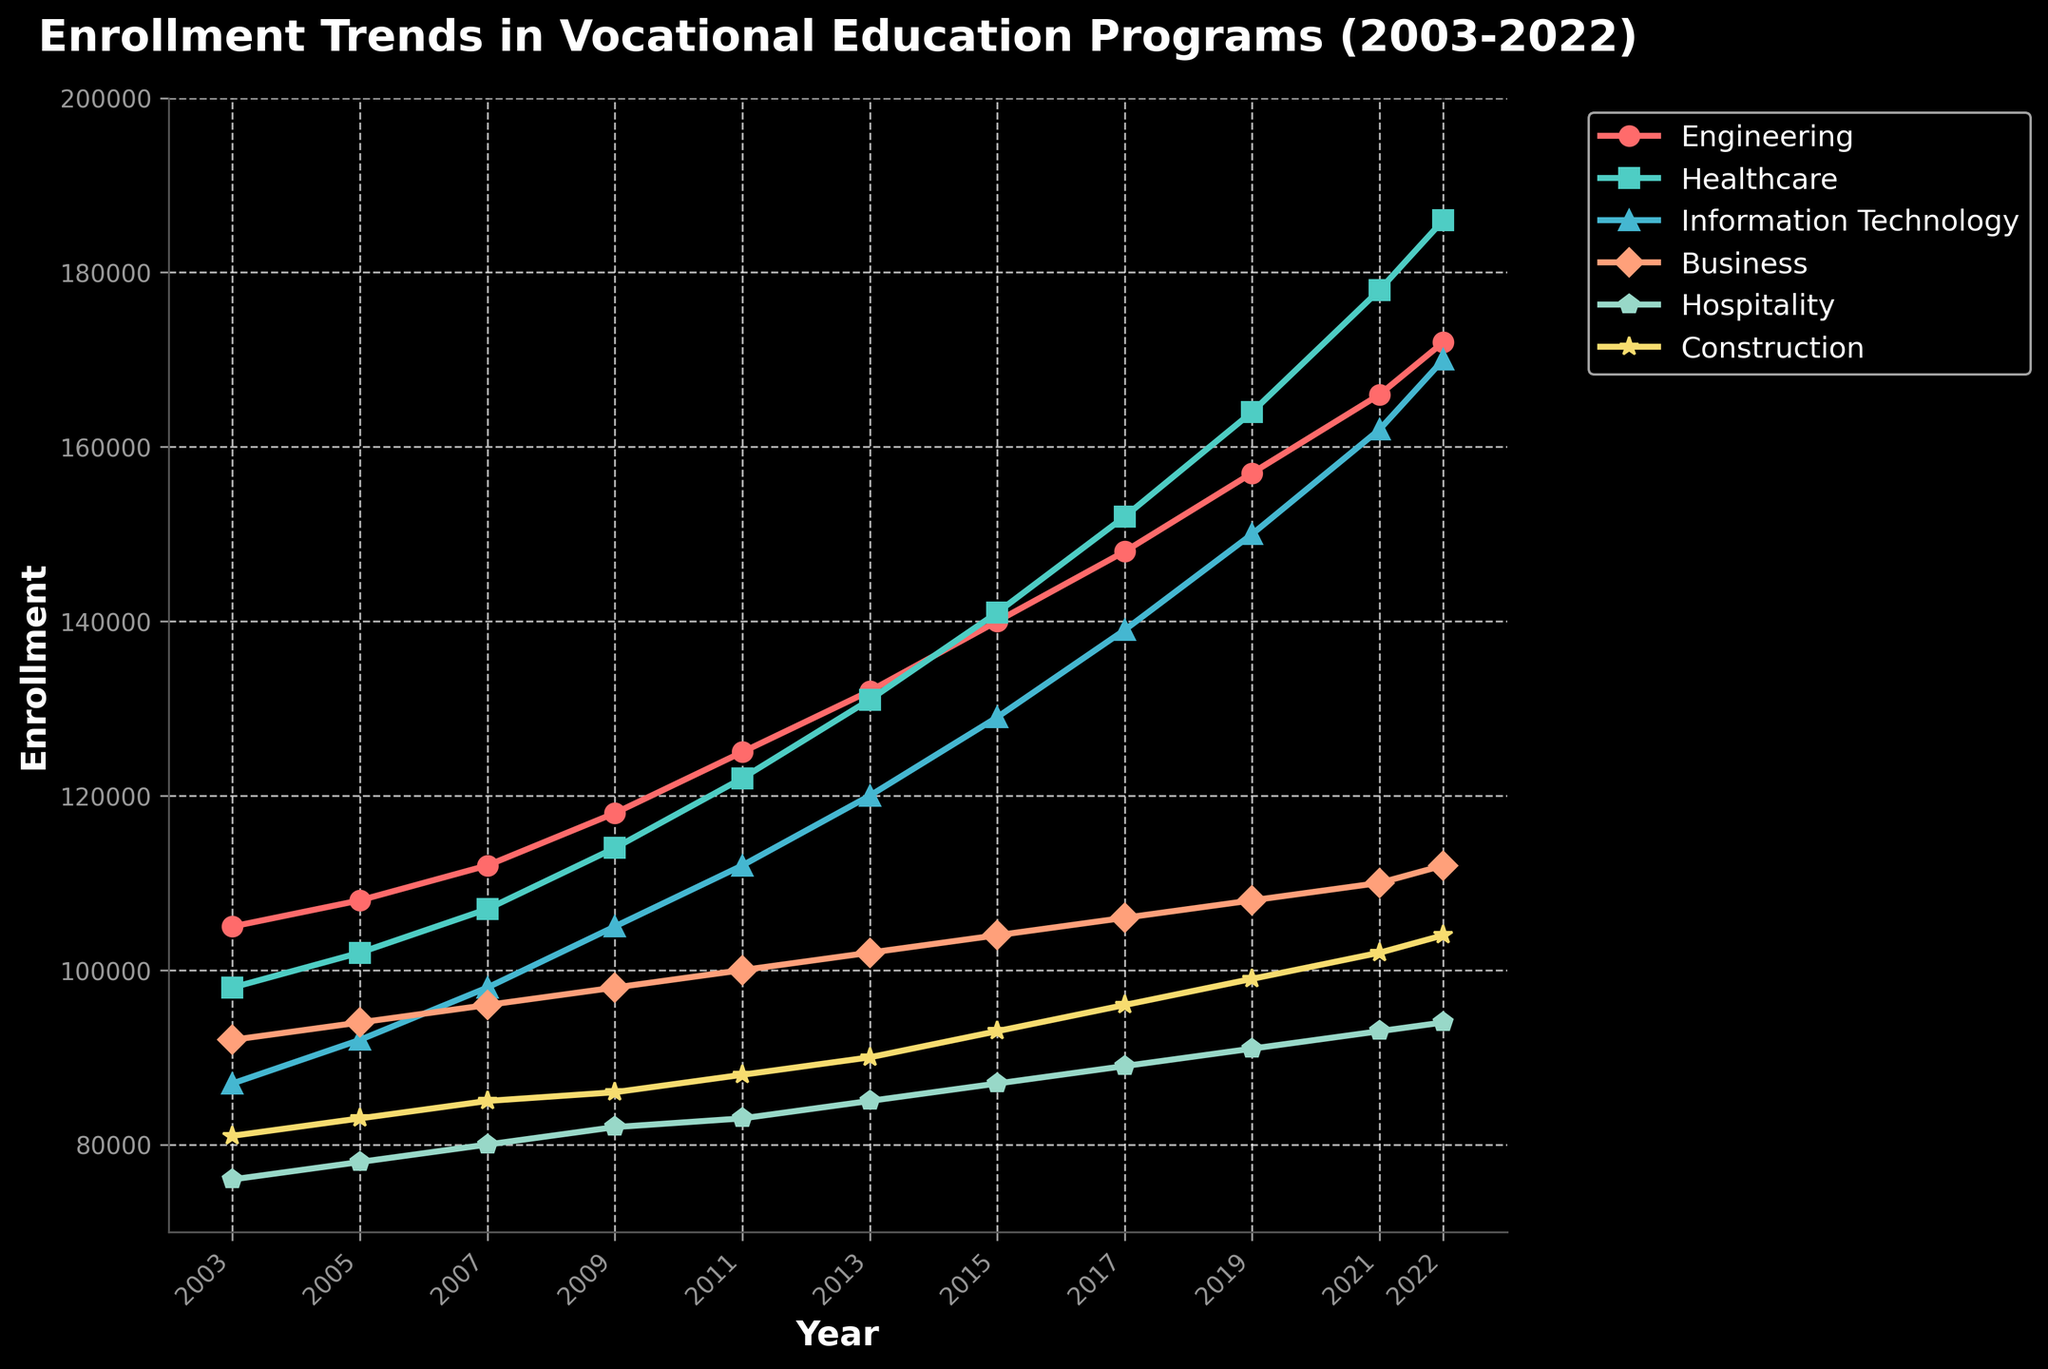What field of study had the highest enrollment in 2022? By looking at the highest point in the chart under the year 2022, we can identify the field with the maximum enrollment. The highest peak corresponds to Healthcare.
Answer: Healthcare How did the enrollment in Engineering change from 2011 to 2021? Observe the points corresponding to Engineering for the years 2011 and 2021. For Engineering, enrollment was 125,000 in 2011 and increased to 166,000 in 2021. Therefore, the change is calculated as 166,000 - 125,000 = 41,000.
Answer: Increased by 41,000 Between which consecutive years did Construction see the highest increase in enrollment? Examine the increments in enrollment for Construction between each pair of consecutive years. The highest increase is observed between 2021 (102,000) and 2022 (104,000), which is 104,000 - 102,000 = 2,000.
Answer: Between 2021 and 2022 Which field saw the most significant overall increase in enrollment from 2003 to 2022? Calculate the differences in enrollments for each field from 2003 to 2022. The differences are: Engineering (172,000 - 105,000 = 67,000), Healthcare (186,000 - 98,000 = 88,000), Information Technology (170,000 - 87,000 = 83,000), Business (112,000 - 92,000 = 20,000), Hospitality (94,000 - 76,000 = 18,000), Construction (104,000 - 81,000 = 23,000). Healthcare has the highest increase (88,000).
Answer: Healthcare In which year did Information Technology surpass 100,000 enrollments for the first time? Look at the points corresponding to Information Technology and find the first year where the enrollment exceeds 100,000. It surpasses 100,000 in 2009 with 105,000 enrollments.
Answer: 2009 What is the average enrollment in Business between 2005 and 2015? Identify the enrollment numbers for Business in the years 2005 (94,000), 2007 (96,000), 2009 (98,000), 2011 (100,000), 2013 (102,000), and 2015 (104,000). Average = (94,000 + 96,000 + 98,000 + 100,000 + 102,000 + 104,000) / 6 = 99,000.
Answer: 99,000 Which field experienced the least variability in enrollment over the period observed? Variability can be judged by how much the enrollment numbers fluctuate over the years. By observing the consistency of the lines, Business shows the least variability compared to other fields with not much fluctuation in the trend.
Answer: Business What was the total combined enrollment for all fields in 2019? Sum up the enrollment numbers for the year 2019 across all fields: Engineering (157,000), Healthcare (164,000), IT (150,000), Business (108,000), Hospitality (91,000), Construction (99,000). Total = 157,000 + 164,000 + 150,000 + 108,000 + 91,000 + 99,000 = 769,000.
Answer: 769,000 How does the enrollment trend in Hospitality compare to that in Construction? Observe the trends for both Hospitality and Construction. Both display a steady increase over time, but the rise in Construction is more linear and gradual, whereas Hospitality shows slight fluctuations. Overall, both trends are positive, but Construction increases more consistently.
Answer: Both increase, Construction more consistently Which year saw the highest enrollment increase for Healthcare compared to the previous year? By evaluating the year-to-year increments for Healthcare: highest increase is between 2020 and 2021 (178,000 - 164,000 = 14,000).
Answer: 2021 